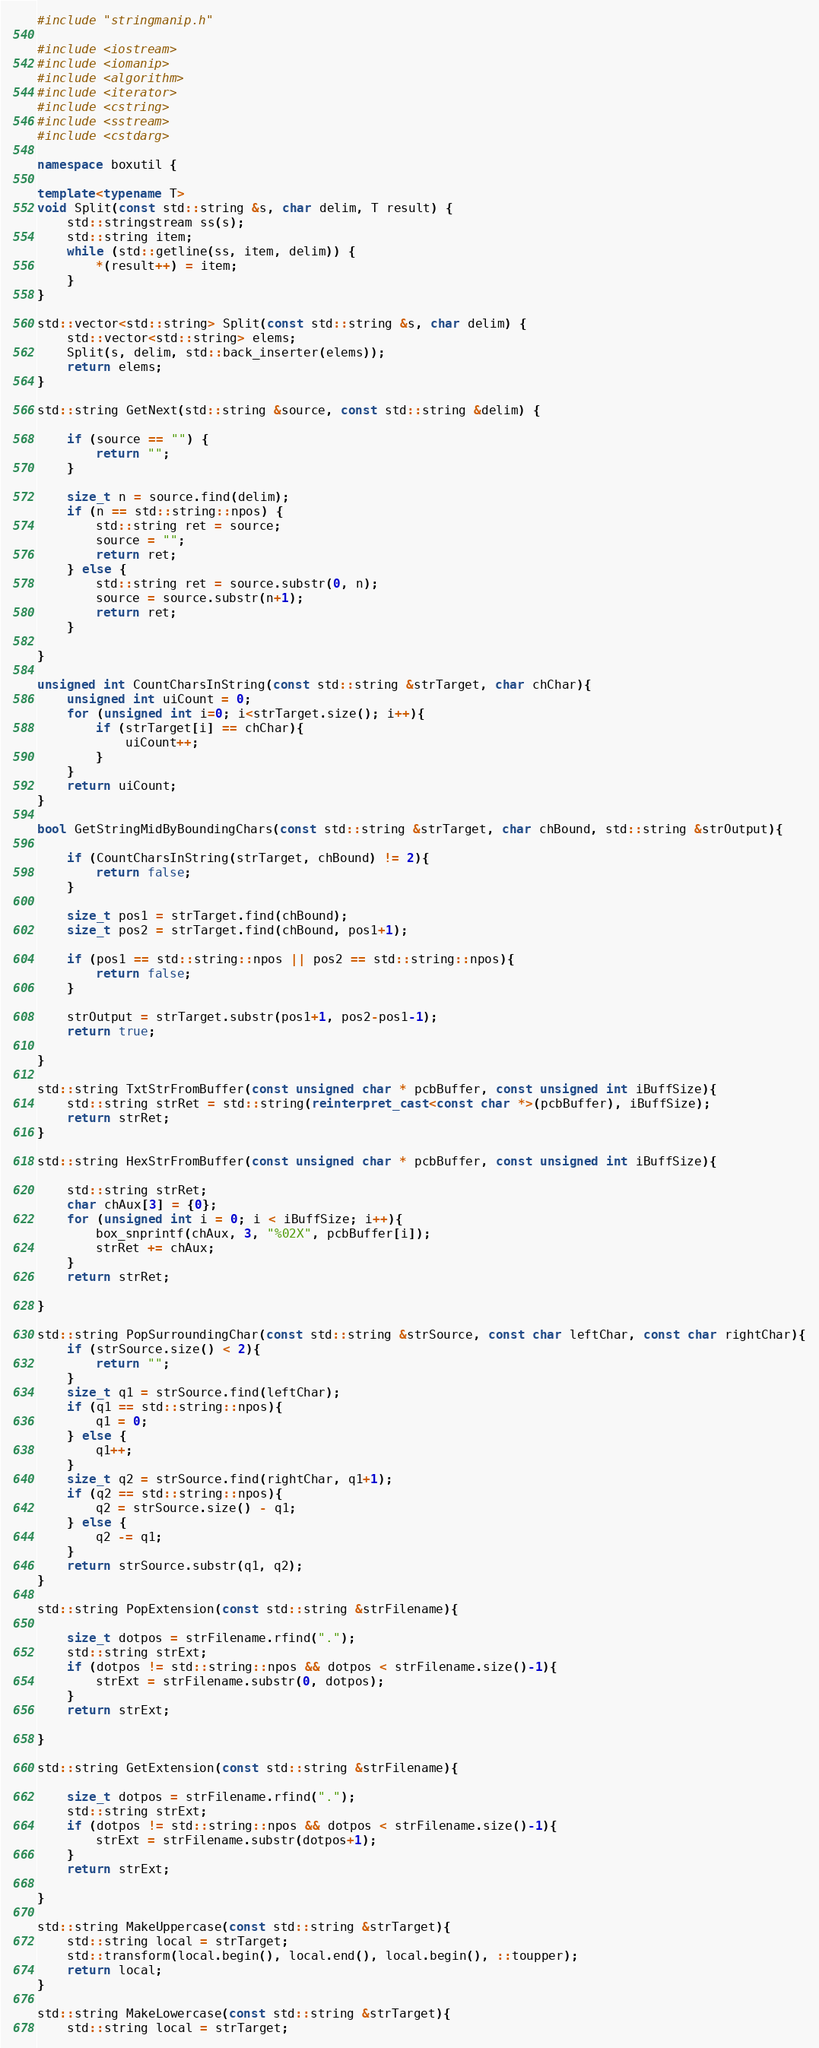Convert code to text. <code><loc_0><loc_0><loc_500><loc_500><_C++_>
#include "stringmanip.h"

#include <iostream>
#include <iomanip>
#include <algorithm>
#include <iterator>
#include <cstring>
#include <sstream>
#include <cstdarg>

namespace boxutil {

template<typename T>
void Split(const std::string &s, char delim, T result) {
    std::stringstream ss(s);
    std::string item;
    while (std::getline(ss, item, delim)) {
        *(result++) = item;
    }
}

std::vector<std::string> Split(const std::string &s, char delim) {
    std::vector<std::string> elems;
    Split(s, delim, std::back_inserter(elems));
    return elems;
}

std::string GetNext(std::string &source, const std::string &delim) {

    if (source == "") {
        return "";
    }

    size_t n = source.find(delim);
    if (n == std::string::npos) {
        std::string ret = source;
        source = "";
        return ret;
    } else {
        std::string ret = source.substr(0, n);
        source = source.substr(n+1);
        return ret;
    }

}

unsigned int CountCharsInString(const std::string &strTarget, char chChar){
    unsigned int uiCount = 0;
    for (unsigned int i=0; i<strTarget.size(); i++){
        if (strTarget[i] == chChar){
            uiCount++;
        }
    }
    return uiCount;
}

bool GetStringMidByBoundingChars(const std::string &strTarget, char chBound, std::string &strOutput){

    if (CountCharsInString(strTarget, chBound) != 2){
        return false;
    }

    size_t pos1 = strTarget.find(chBound);
    size_t pos2 = strTarget.find(chBound, pos1+1);

    if (pos1 == std::string::npos || pos2 == std::string::npos){
        return false;
    }

    strOutput = strTarget.substr(pos1+1, pos2-pos1-1);
    return true;

}

std::string TxtStrFromBuffer(const unsigned char * pcbBuffer, const unsigned int iBuffSize){
    std::string strRet = std::string(reinterpret_cast<const char *>(pcbBuffer), iBuffSize);
    return strRet;
}

std::string HexStrFromBuffer(const unsigned char * pcbBuffer, const unsigned int iBuffSize){

    std::string strRet;
    char chAux[3] = {0};
    for (unsigned int i = 0; i < iBuffSize; i++){
        box_snprintf(chAux, 3, "%02X", pcbBuffer[i]);
        strRet += chAux;
    }
    return strRet;

}

std::string PopSurroundingChar(const std::string &strSource, const char leftChar, const char rightChar){
    if (strSource.size() < 2){
        return "";
    }
    size_t q1 = strSource.find(leftChar);
    if (q1 == std::string::npos){
        q1 = 0;
    } else {
        q1++;
    }
    size_t q2 = strSource.find(rightChar, q1+1);
    if (q2 == std::string::npos){
        q2 = strSource.size() - q1;
    } else {
        q2 -= q1;
    }
    return strSource.substr(q1, q2);
}

std::string PopExtension(const std::string &strFilename){

    size_t dotpos = strFilename.rfind(".");
    std::string strExt;
    if (dotpos != std::string::npos && dotpos < strFilename.size()-1){
        strExt = strFilename.substr(0, dotpos);
    }
    return strExt;

}

std::string GetExtension(const std::string &strFilename){

    size_t dotpos = strFilename.rfind(".");
    std::string strExt;
    if (dotpos != std::string::npos && dotpos < strFilename.size()-1){
        strExt = strFilename.substr(dotpos+1);
    }
    return strExt;

}

std::string MakeUppercase(const std::string &strTarget){
    std::string local = strTarget;
    std::transform(local.begin(), local.end(), local.begin(), ::toupper);
    return local;
}

std::string MakeLowercase(const std::string &strTarget){
    std::string local = strTarget;</code> 